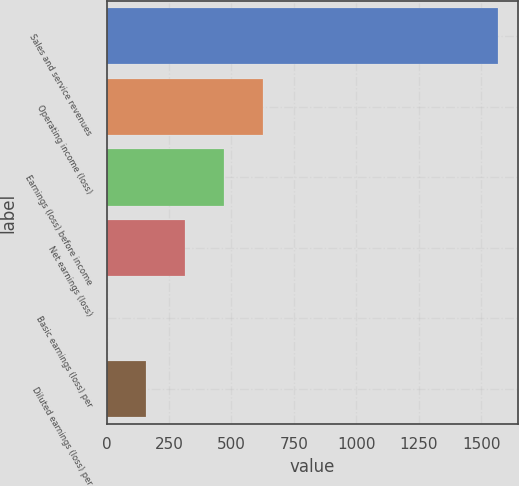Convert chart to OTSL. <chart><loc_0><loc_0><loc_500><loc_500><bar_chart><fcel>Sales and service revenues<fcel>Operating income (loss)<fcel>Earnings (loss) before income<fcel>Net earnings (loss)<fcel>Basic earnings (loss) per<fcel>Diluted earnings (loss) per<nl><fcel>1568<fcel>627.59<fcel>470.86<fcel>314.13<fcel>0.67<fcel>157.4<nl></chart> 